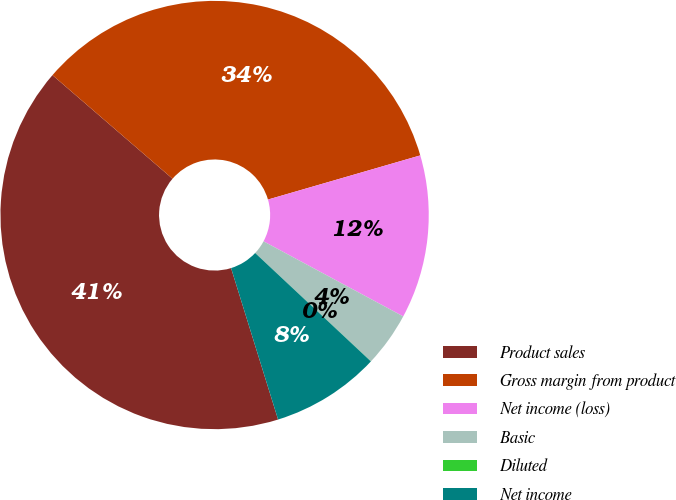<chart> <loc_0><loc_0><loc_500><loc_500><pie_chart><fcel>Product sales<fcel>Gross margin from product<fcel>Net income (loss)<fcel>Basic<fcel>Diluted<fcel>Net income<nl><fcel>41.12%<fcel>34.18%<fcel>12.34%<fcel>4.12%<fcel>0.01%<fcel>8.23%<nl></chart> 